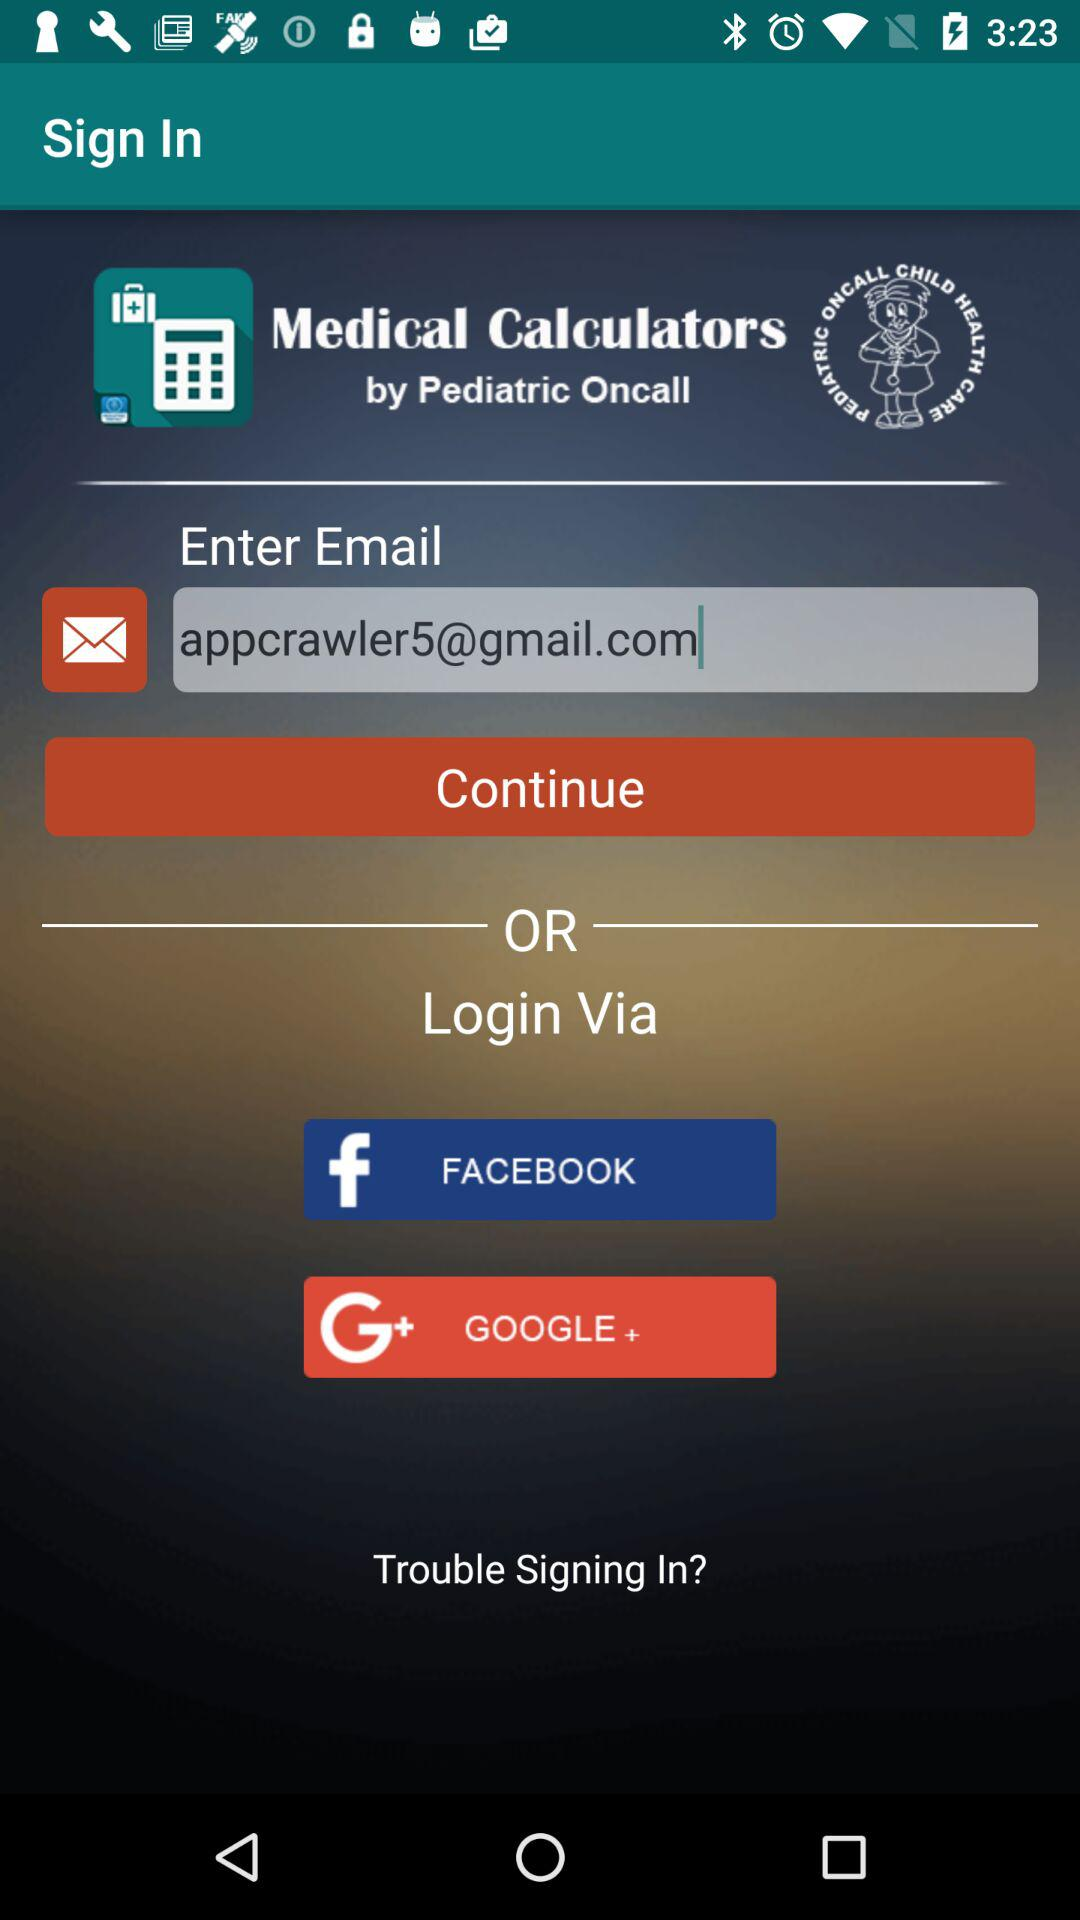What are the other options to log in? The other options to log in are "FACEBOOK" and "GOOGLE +". 